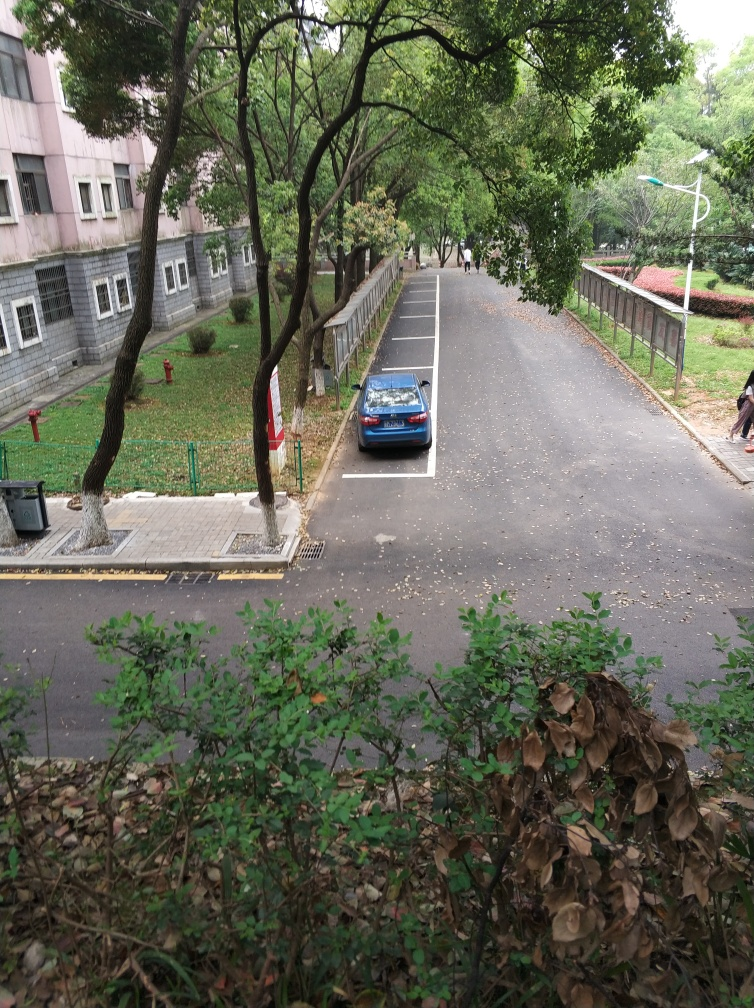Is the background of the image clear? The background of the image is moderately clear. The foliage and the parked car are distinct, but further details fade slightly into the distance due to the aerial perspective. 